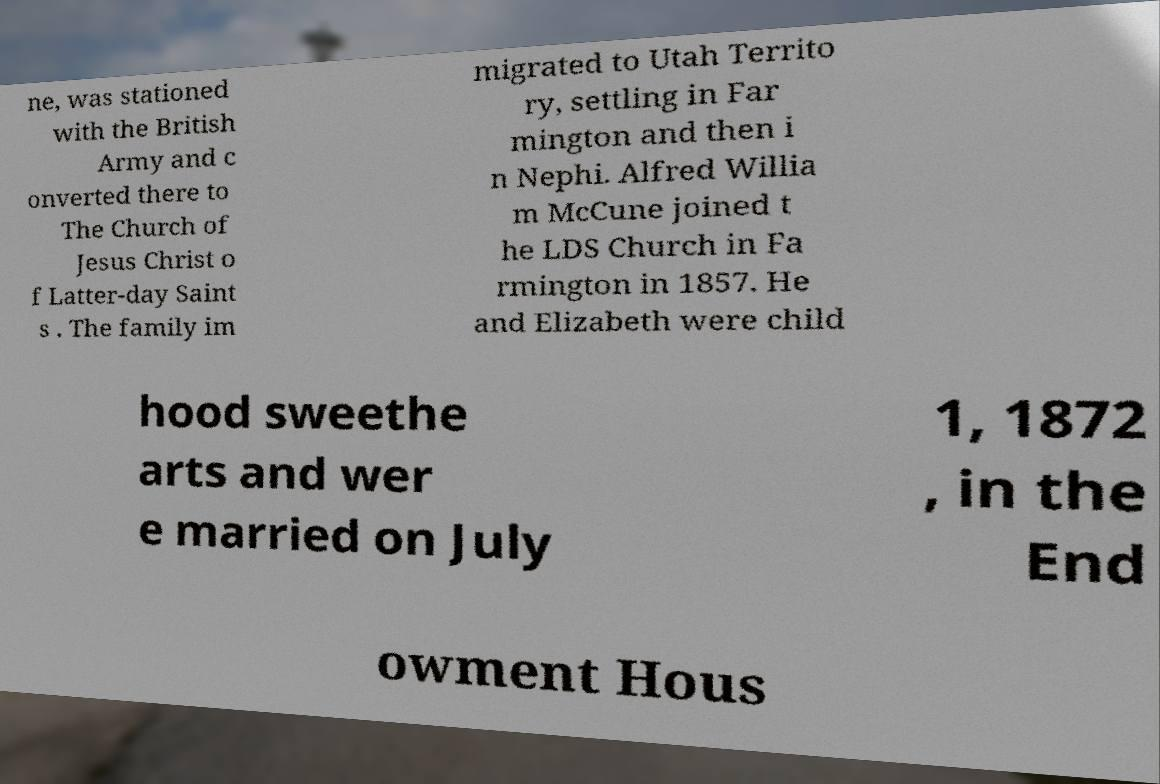Could you assist in decoding the text presented in this image and type it out clearly? ne, was stationed with the British Army and c onverted there to The Church of Jesus Christ o f Latter-day Saint s . The family im migrated to Utah Territo ry, settling in Far mington and then i n Nephi. Alfred Willia m McCune joined t he LDS Church in Fa rmington in 1857. He and Elizabeth were child hood sweethe arts and wer e married on July 1, 1872 , in the End owment Hous 